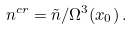<formula> <loc_0><loc_0><loc_500><loc_500>{ n } ^ { c r } = \tilde { n } / \Omega ^ { 3 } ( x _ { 0 } ) \, .</formula> 